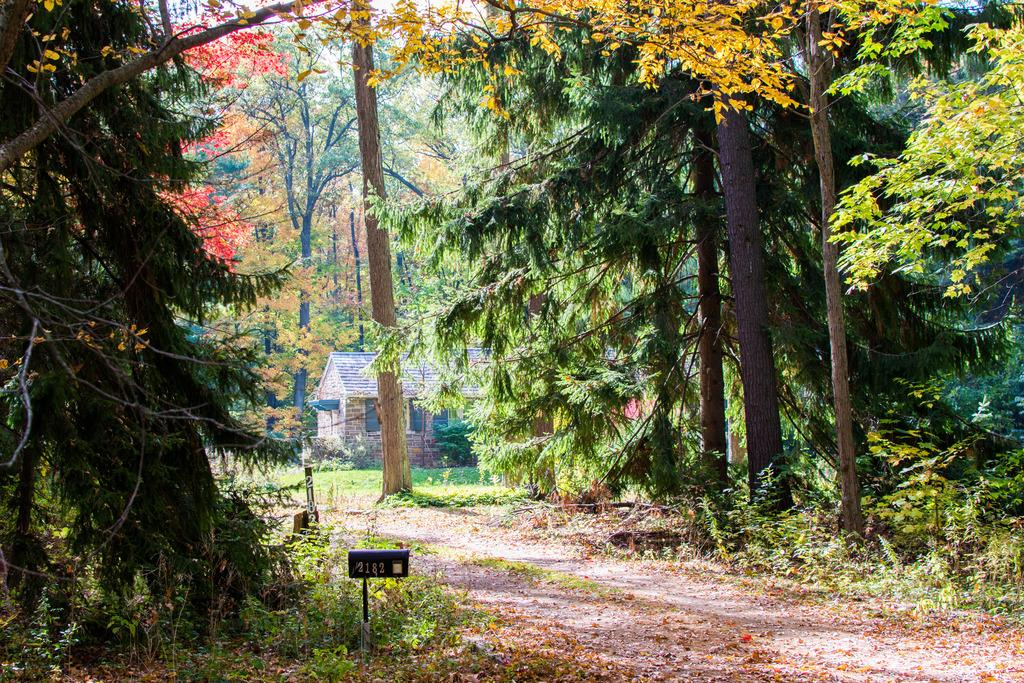What is the main feature of the image? There is a road in the image. What can be seen on the sides of the road? There are trees on the sides of the road. What is visible in the background of the image? There is a building in the background of the image. What type of boat can be seen sailing on the road in the image? There is no boat present in the image, as it features a road with trees on the sides and a building in the background. 